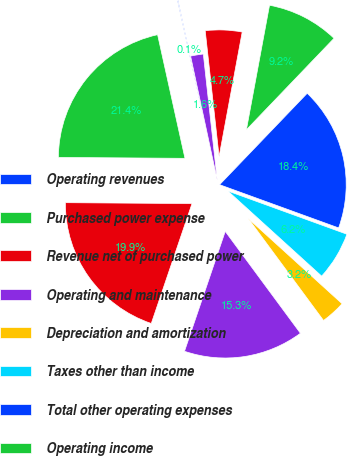Convert chart. <chart><loc_0><loc_0><loc_500><loc_500><pie_chart><fcel>Operating revenues<fcel>Purchased power expense<fcel>Revenue net of purchased power<fcel>Operating and maintenance<fcel>Depreciation and amortization<fcel>Taxes other than income<fcel>Total other operating expenses<fcel>Operating income<fcel>Interest expense net<fcel>Equity in losses of<nl><fcel>0.1%<fcel>21.42%<fcel>19.9%<fcel>15.33%<fcel>3.15%<fcel>6.19%<fcel>18.38%<fcel>9.24%<fcel>4.67%<fcel>1.62%<nl></chart> 